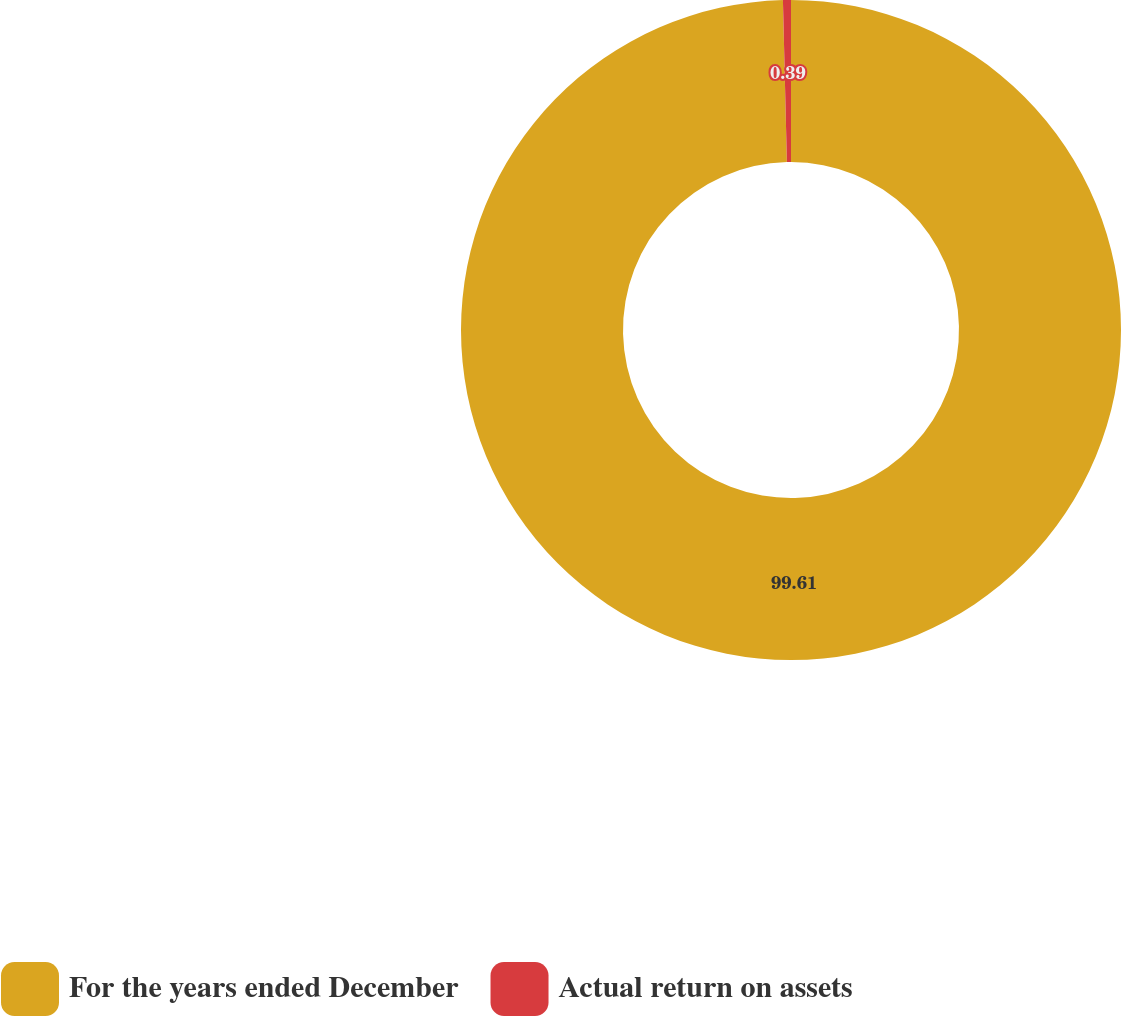<chart> <loc_0><loc_0><loc_500><loc_500><pie_chart><fcel>For the years ended December<fcel>Actual return on assets<nl><fcel>99.61%<fcel>0.39%<nl></chart> 